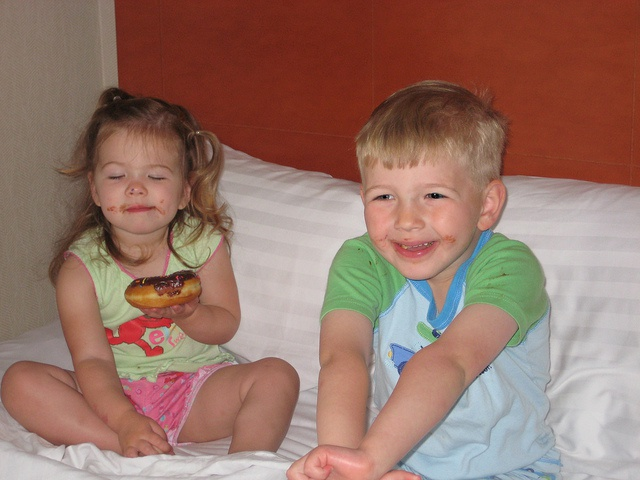Describe the objects in this image and their specific colors. I can see bed in gray, maroon, brown, darkgray, and lightgray tones, people in gray, tan, darkgray, and salmon tones, people in gray, brown, tan, darkgray, and maroon tones, and donut in gray, brown, maroon, black, and tan tones in this image. 